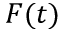Convert formula to latex. <formula><loc_0><loc_0><loc_500><loc_500>F ( t )</formula> 